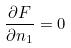<formula> <loc_0><loc_0><loc_500><loc_500>\frac { \partial F } { \partial n _ { 1 } } = 0</formula> 